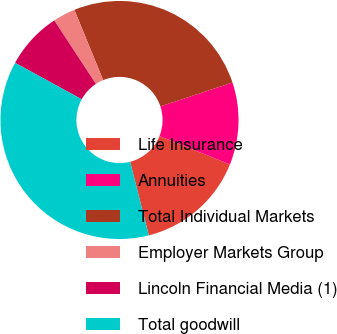Convert chart. <chart><loc_0><loc_0><loc_500><loc_500><pie_chart><fcel>Life Insurance<fcel>Annuities<fcel>Total Individual Markets<fcel>Employer Markets Group<fcel>Lincoln Financial Media (1)<fcel>Total goodwill<nl><fcel>14.95%<fcel>11.19%<fcel>26.09%<fcel>3.04%<fcel>7.8%<fcel>36.93%<nl></chart> 